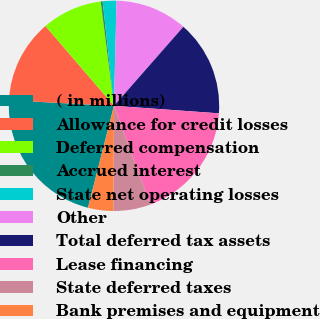Convert chart to OTSL. <chart><loc_0><loc_0><loc_500><loc_500><pie_chart><fcel>( in millions)<fcel>Allowance for credit losses<fcel>Deferred compensation<fcel>Accrued interest<fcel>State net operating losses<fcel>Other<fcel>Total deferred tax assets<fcel>Lease financing<fcel>State deferred taxes<fcel>Bank premises and equipment<nl><fcel>21.86%<fcel>12.87%<fcel>9.28%<fcel>0.3%<fcel>2.1%<fcel>11.08%<fcel>14.67%<fcel>18.26%<fcel>5.69%<fcel>3.89%<nl></chart> 